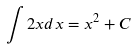<formula> <loc_0><loc_0><loc_500><loc_500>\int 2 x d x = x ^ { 2 } + C</formula> 